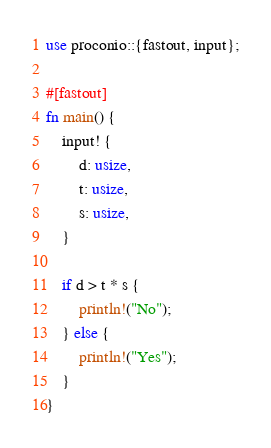<code> <loc_0><loc_0><loc_500><loc_500><_Rust_>use proconio::{fastout, input};

#[fastout]
fn main() {
    input! {
        d: usize,
        t: usize,
        s: usize,
    }

    if d > t * s {
        println!("No");
    } else {
        println!("Yes");
    }
}
</code> 